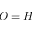Convert formula to latex. <formula><loc_0><loc_0><loc_500><loc_500>O = H</formula> 